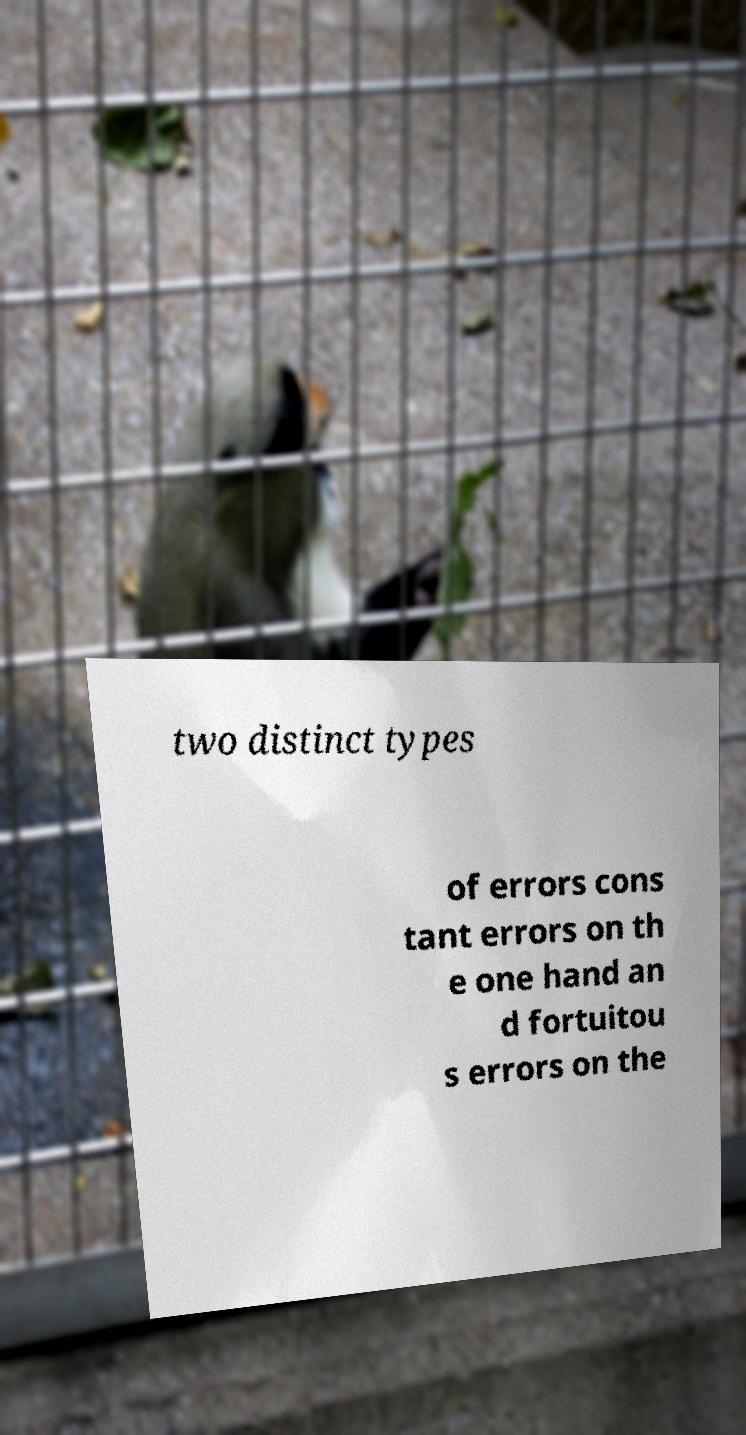Please identify and transcribe the text found in this image. two distinct types of errors cons tant errors on th e one hand an d fortuitou s errors on the 